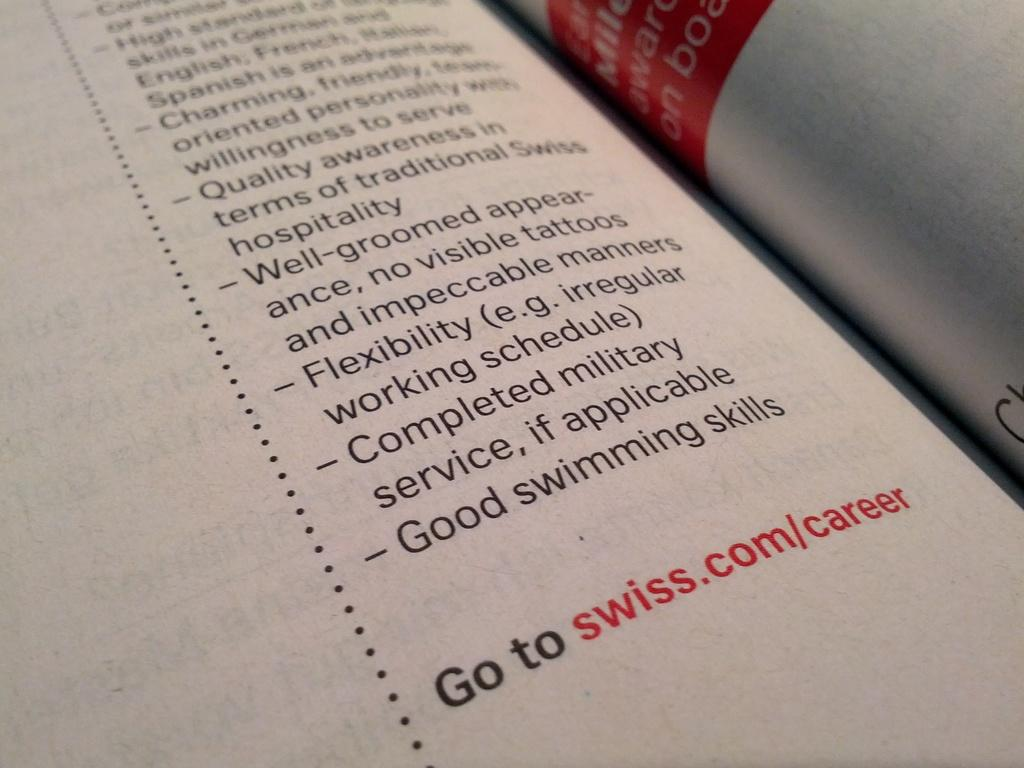<image>
Write a terse but informative summary of the picture. A page of a book with a website for swiss.com/career at the bottom 